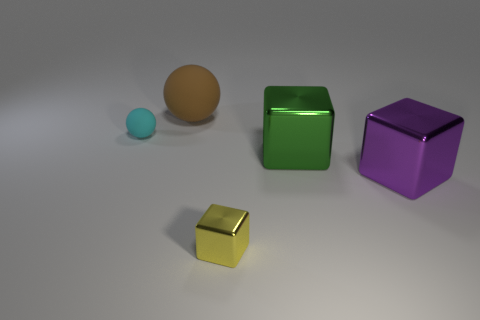Add 2 tiny gray rubber cylinders. How many objects exist? 7 Subtract all blocks. How many objects are left? 2 Add 1 tiny shiny cubes. How many tiny shiny cubes are left? 2 Add 4 cyan rubber cylinders. How many cyan rubber cylinders exist? 4 Subtract 1 green cubes. How many objects are left? 4 Subtract all large red metal balls. Subtract all big brown things. How many objects are left? 4 